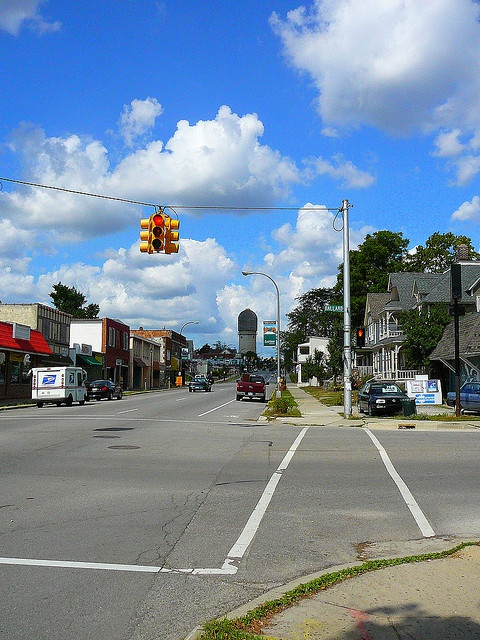Describe the objects in this image and their specific colors. I can see truck in gray, white, black, and darkgray tones, car in gray, black, darkgray, and teal tones, truck in gray, black, maroon, and darkgray tones, car in gray, black, blue, and navy tones, and car in gray, black, navy, and blue tones in this image. 